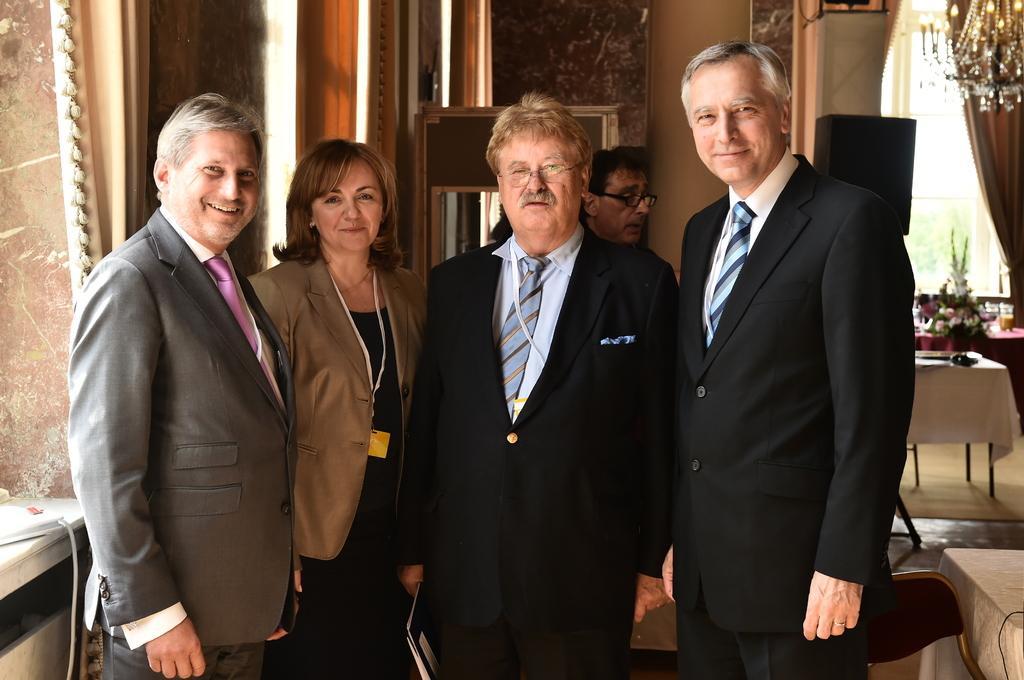Please provide a concise description of this image. In the foreground of this image, there are persons standing. In the background, there are chairs, tables, chandelier, window, curtain, wall, an object and another curtain is on the left side. 